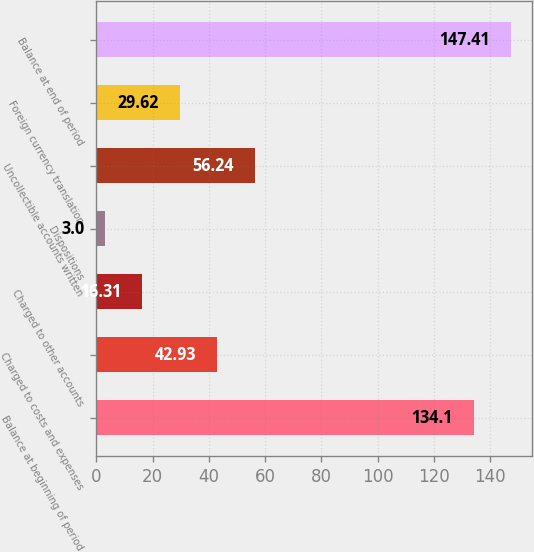Convert chart. <chart><loc_0><loc_0><loc_500><loc_500><bar_chart><fcel>Balance at beginning of period<fcel>Charged to costs and expenses<fcel>Charged to other accounts<fcel>Dispositions<fcel>Uncollectible accounts written<fcel>Foreign currency translation<fcel>Balance at end of period<nl><fcel>134.1<fcel>42.93<fcel>16.31<fcel>3<fcel>56.24<fcel>29.62<fcel>147.41<nl></chart> 